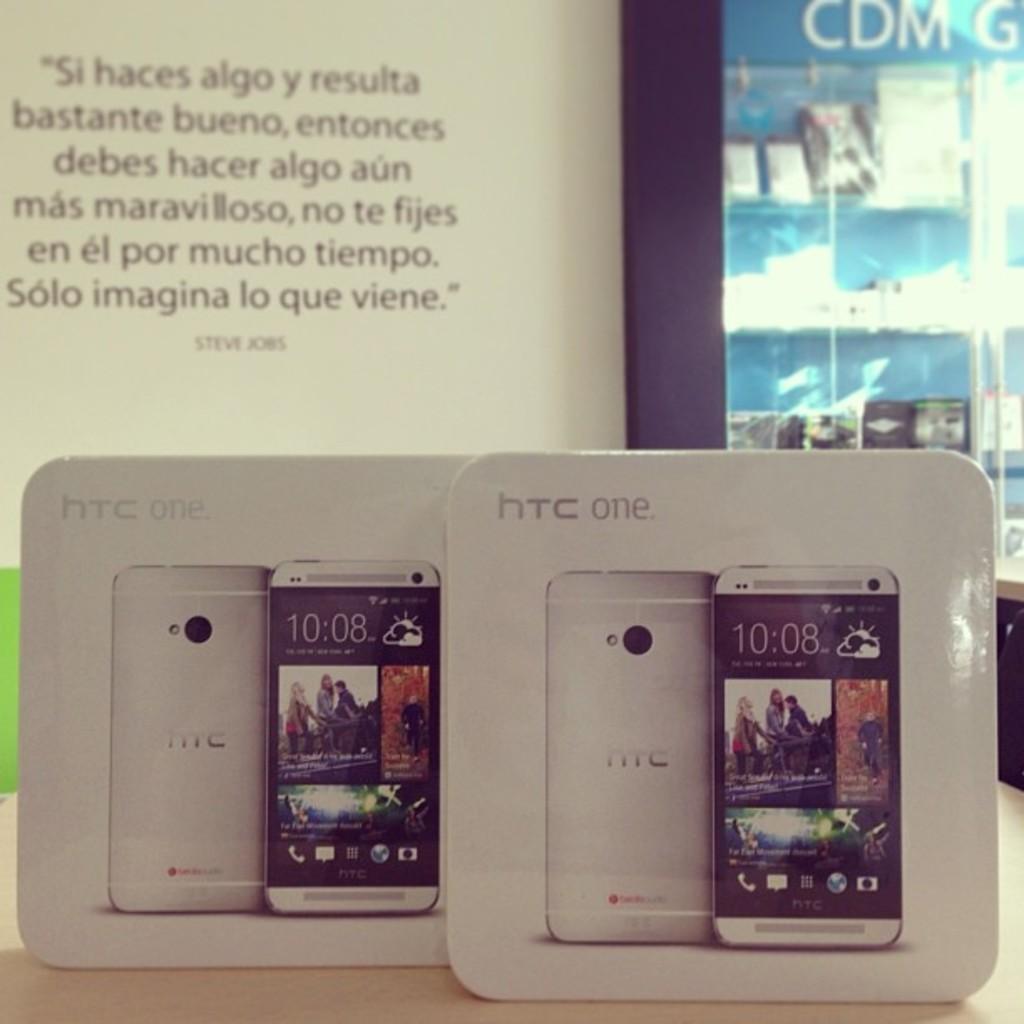What type of phones are these?
Offer a very short reply. Htc one. Who is the quote at the top left by?
Your response must be concise. Steve jobs. 